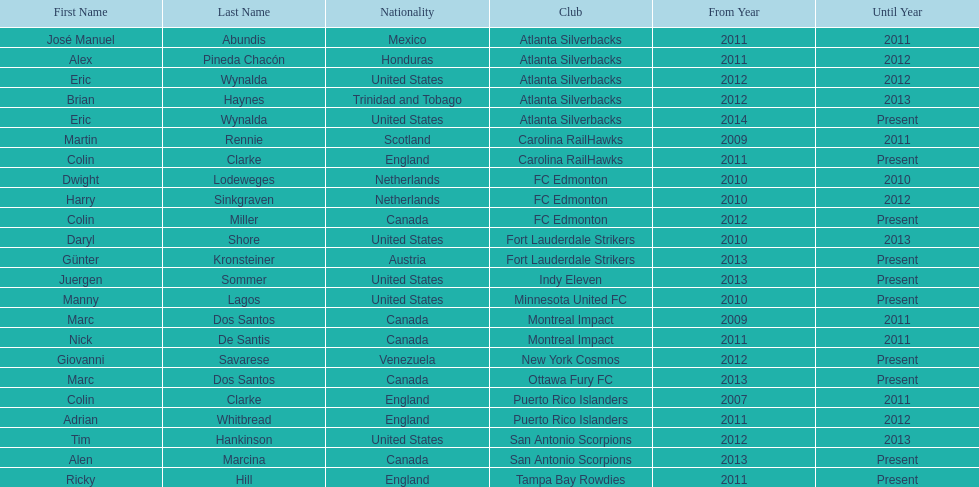Could you help me parse every detail presented in this table? {'header': ['First Name', 'Last Name', 'Nationality', 'Club', 'From Year', 'Until Year'], 'rows': [['José Manuel', 'Abundis', 'Mexico', 'Atlanta Silverbacks', '2011', '2011'], ['Alex', 'Pineda Chacón', 'Honduras', 'Atlanta Silverbacks', '2011', '2012'], ['Eric', 'Wynalda', 'United States', 'Atlanta Silverbacks', '2012', '2012'], ['Brian', 'Haynes', 'Trinidad and Tobago', 'Atlanta Silverbacks', '2012', '2013'], ['Eric', 'Wynalda', 'United States', 'Atlanta Silverbacks', '2014', 'Present'], ['Martin', 'Rennie', 'Scotland', 'Carolina RailHawks', '2009', '2011'], ['Colin', 'Clarke', 'England', 'Carolina RailHawks', '2011', 'Present'], ['Dwight', 'Lodeweges', 'Netherlands', 'FC Edmonton', '2010', '2010'], ['Harry', 'Sinkgraven', 'Netherlands', 'FC Edmonton', '2010', '2012'], ['Colin', 'Miller', 'Canada', 'FC Edmonton', '2012', 'Present'], ['Daryl', 'Shore', 'United States', 'Fort Lauderdale Strikers', '2010', '2013'], ['Günter', 'Kronsteiner', 'Austria', 'Fort Lauderdale Strikers', '2013', 'Present'], ['Juergen', 'Sommer', 'United States', 'Indy Eleven', '2013', 'Present'], ['Manny', 'Lagos', 'United States', 'Minnesota United FC', '2010', 'Present'], ['Marc', 'Dos Santos', 'Canada', 'Montreal Impact', '2009', '2011'], ['Nick', 'De Santis', 'Canada', 'Montreal Impact', '2011', '2011'], ['Giovanni', 'Savarese', 'Venezuela', 'New York Cosmos', '2012', 'Present'], ['Marc', 'Dos Santos', 'Canada', 'Ottawa Fury FC', '2013', 'Present'], ['Colin', 'Clarke', 'England', 'Puerto Rico Islanders', '2007', '2011'], ['Adrian', 'Whitbread', 'England', 'Puerto Rico Islanders', '2011', '2012'], ['Tim', 'Hankinson', 'United States', 'San Antonio Scorpions', '2012', '2013'], ['Alen', 'Marcina', 'Canada', 'San Antonio Scorpions', '2013', 'Present'], ['Ricky', 'Hill', 'England', 'Tampa Bay Rowdies', '2011', 'Present']]} What same country did marc dos santos coach as colin miller? Canada. 